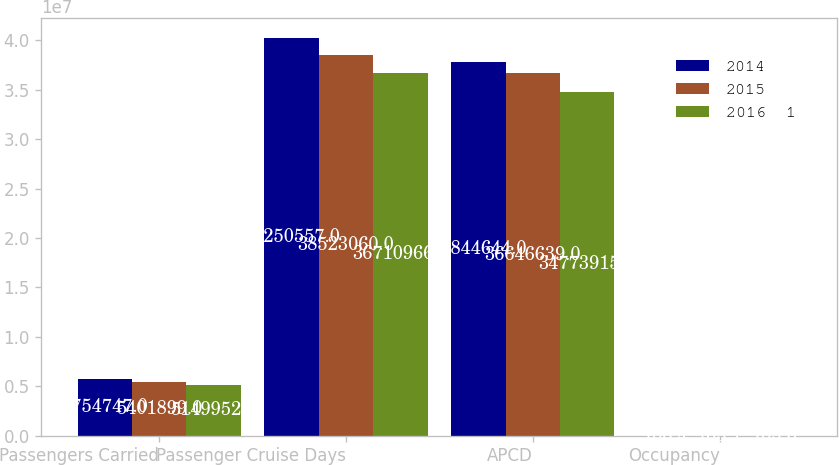Convert chart to OTSL. <chart><loc_0><loc_0><loc_500><loc_500><stacked_bar_chart><ecel><fcel>Passengers Carried<fcel>Passenger Cruise Days<fcel>APCD<fcel>Occupancy<nl><fcel>2014<fcel>5.75475e+06<fcel>4.02506e+07<fcel>3.78446e+07<fcel>106.4<nl><fcel>2015<fcel>5.4019e+06<fcel>3.85231e+07<fcel>3.66466e+07<fcel>105.1<nl><fcel>2016  1<fcel>5.14995e+06<fcel>3.6711e+07<fcel>3.47739e+07<fcel>105.6<nl></chart> 